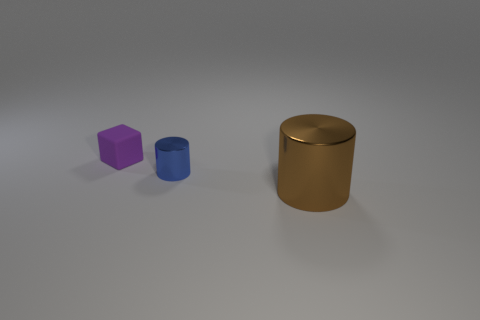How would you describe the lighting in this scene? The lighting in the scene is soft and diffused, likely from an overhead source, as indicated by the subtle shadows under each object. There's no harsh light or strong specular highlights, contributing to a calm and even ambiance.  Can you surmise the time of day if this were outdoors? Though this appears to be a rendered scene and not outdoors, if we were to imagine it as such, the soft and uniform lighting might suggest an overcast day where the sun is obscured, diffusing light evenly across the sky. 